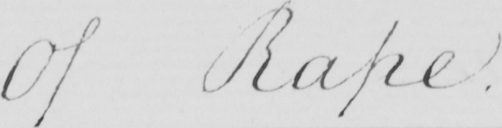What does this handwritten line say? Of Rape 